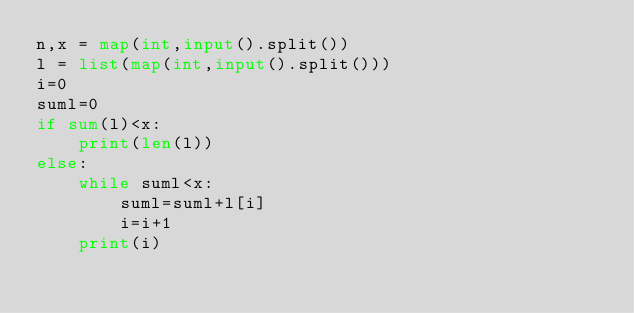<code> <loc_0><loc_0><loc_500><loc_500><_Python_>n,x = map(int,input().split())
l = list(map(int,input().split()))
i=0
suml=0
if sum(l)<x:
    print(len(l))
else:
    while suml<x:
        suml=suml+l[i]
        i=i+1
    print(i)</code> 